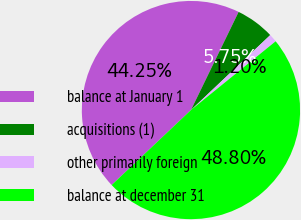Convert chart to OTSL. <chart><loc_0><loc_0><loc_500><loc_500><pie_chart><fcel>balance at January 1<fcel>acquisitions (1)<fcel>other primarily foreign<fcel>balance at december 31<nl><fcel>44.25%<fcel>5.75%<fcel>1.2%<fcel>48.8%<nl></chart> 